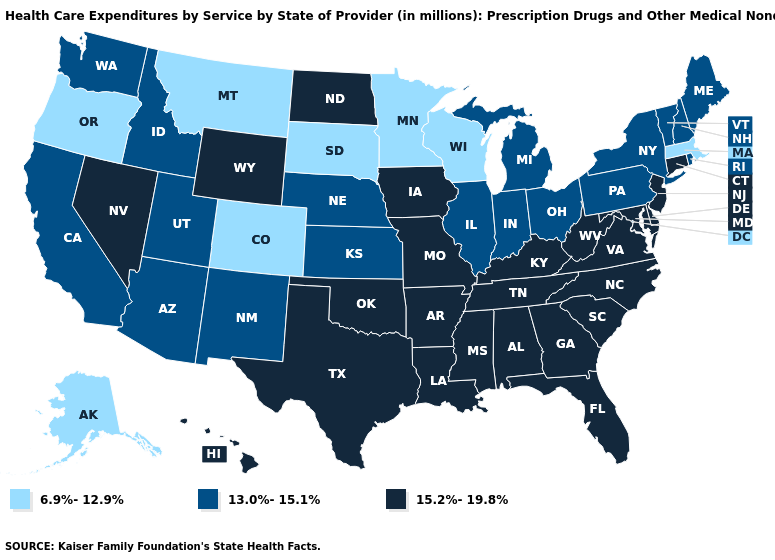Name the states that have a value in the range 15.2%-19.8%?
Be succinct. Alabama, Arkansas, Connecticut, Delaware, Florida, Georgia, Hawaii, Iowa, Kentucky, Louisiana, Maryland, Mississippi, Missouri, Nevada, New Jersey, North Carolina, North Dakota, Oklahoma, South Carolina, Tennessee, Texas, Virginia, West Virginia, Wyoming. What is the highest value in states that border Massachusetts?
Write a very short answer. 15.2%-19.8%. What is the value of Kansas?
Answer briefly. 13.0%-15.1%. Among the states that border South Carolina , which have the lowest value?
Concise answer only. Georgia, North Carolina. Does Indiana have a lower value than Nebraska?
Answer briefly. No. What is the value of Illinois?
Quick response, please. 13.0%-15.1%. Does the map have missing data?
Write a very short answer. No. What is the value of Maine?
Short answer required. 13.0%-15.1%. Name the states that have a value in the range 6.9%-12.9%?
Keep it brief. Alaska, Colorado, Massachusetts, Minnesota, Montana, Oregon, South Dakota, Wisconsin. Among the states that border Utah , does New Mexico have the highest value?
Short answer required. No. Is the legend a continuous bar?
Concise answer only. No. What is the value of Tennessee?
Concise answer only. 15.2%-19.8%. Name the states that have a value in the range 6.9%-12.9%?
Give a very brief answer. Alaska, Colorado, Massachusetts, Minnesota, Montana, Oregon, South Dakota, Wisconsin. 